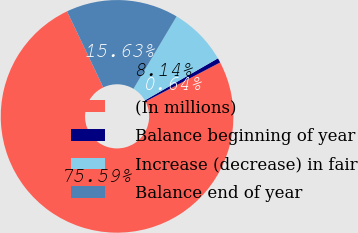Convert chart to OTSL. <chart><loc_0><loc_0><loc_500><loc_500><pie_chart><fcel>(In millions)<fcel>Balance beginning of year<fcel>Increase (decrease) in fair<fcel>Balance end of year<nl><fcel>75.59%<fcel>0.64%<fcel>8.14%<fcel>15.63%<nl></chart> 